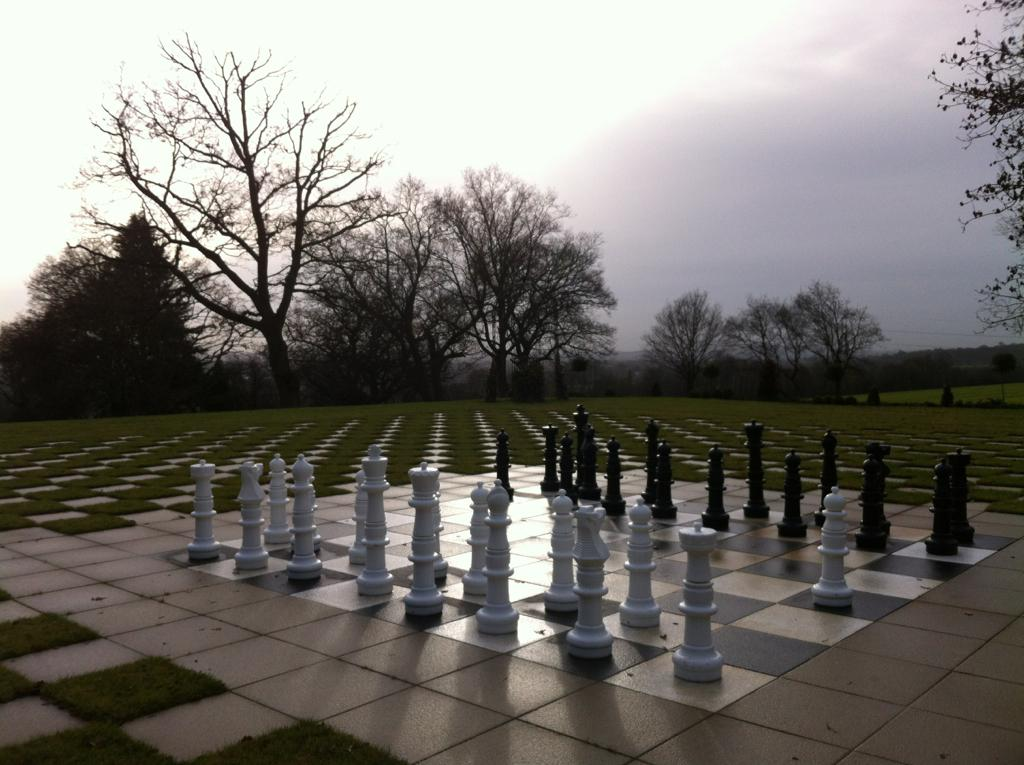What is the condition of the sky in the image? The sky is cloudy in the image. What objects are present on a surface in the image? There are chess pieces on a surface in the image. What can be seen in the background of the image? There are trees in the background of the image. What type of soup is being served in the image? There is no soup present in the image. What color is the skirt worn by the person in the image? There is no person or skirt present in the image. 